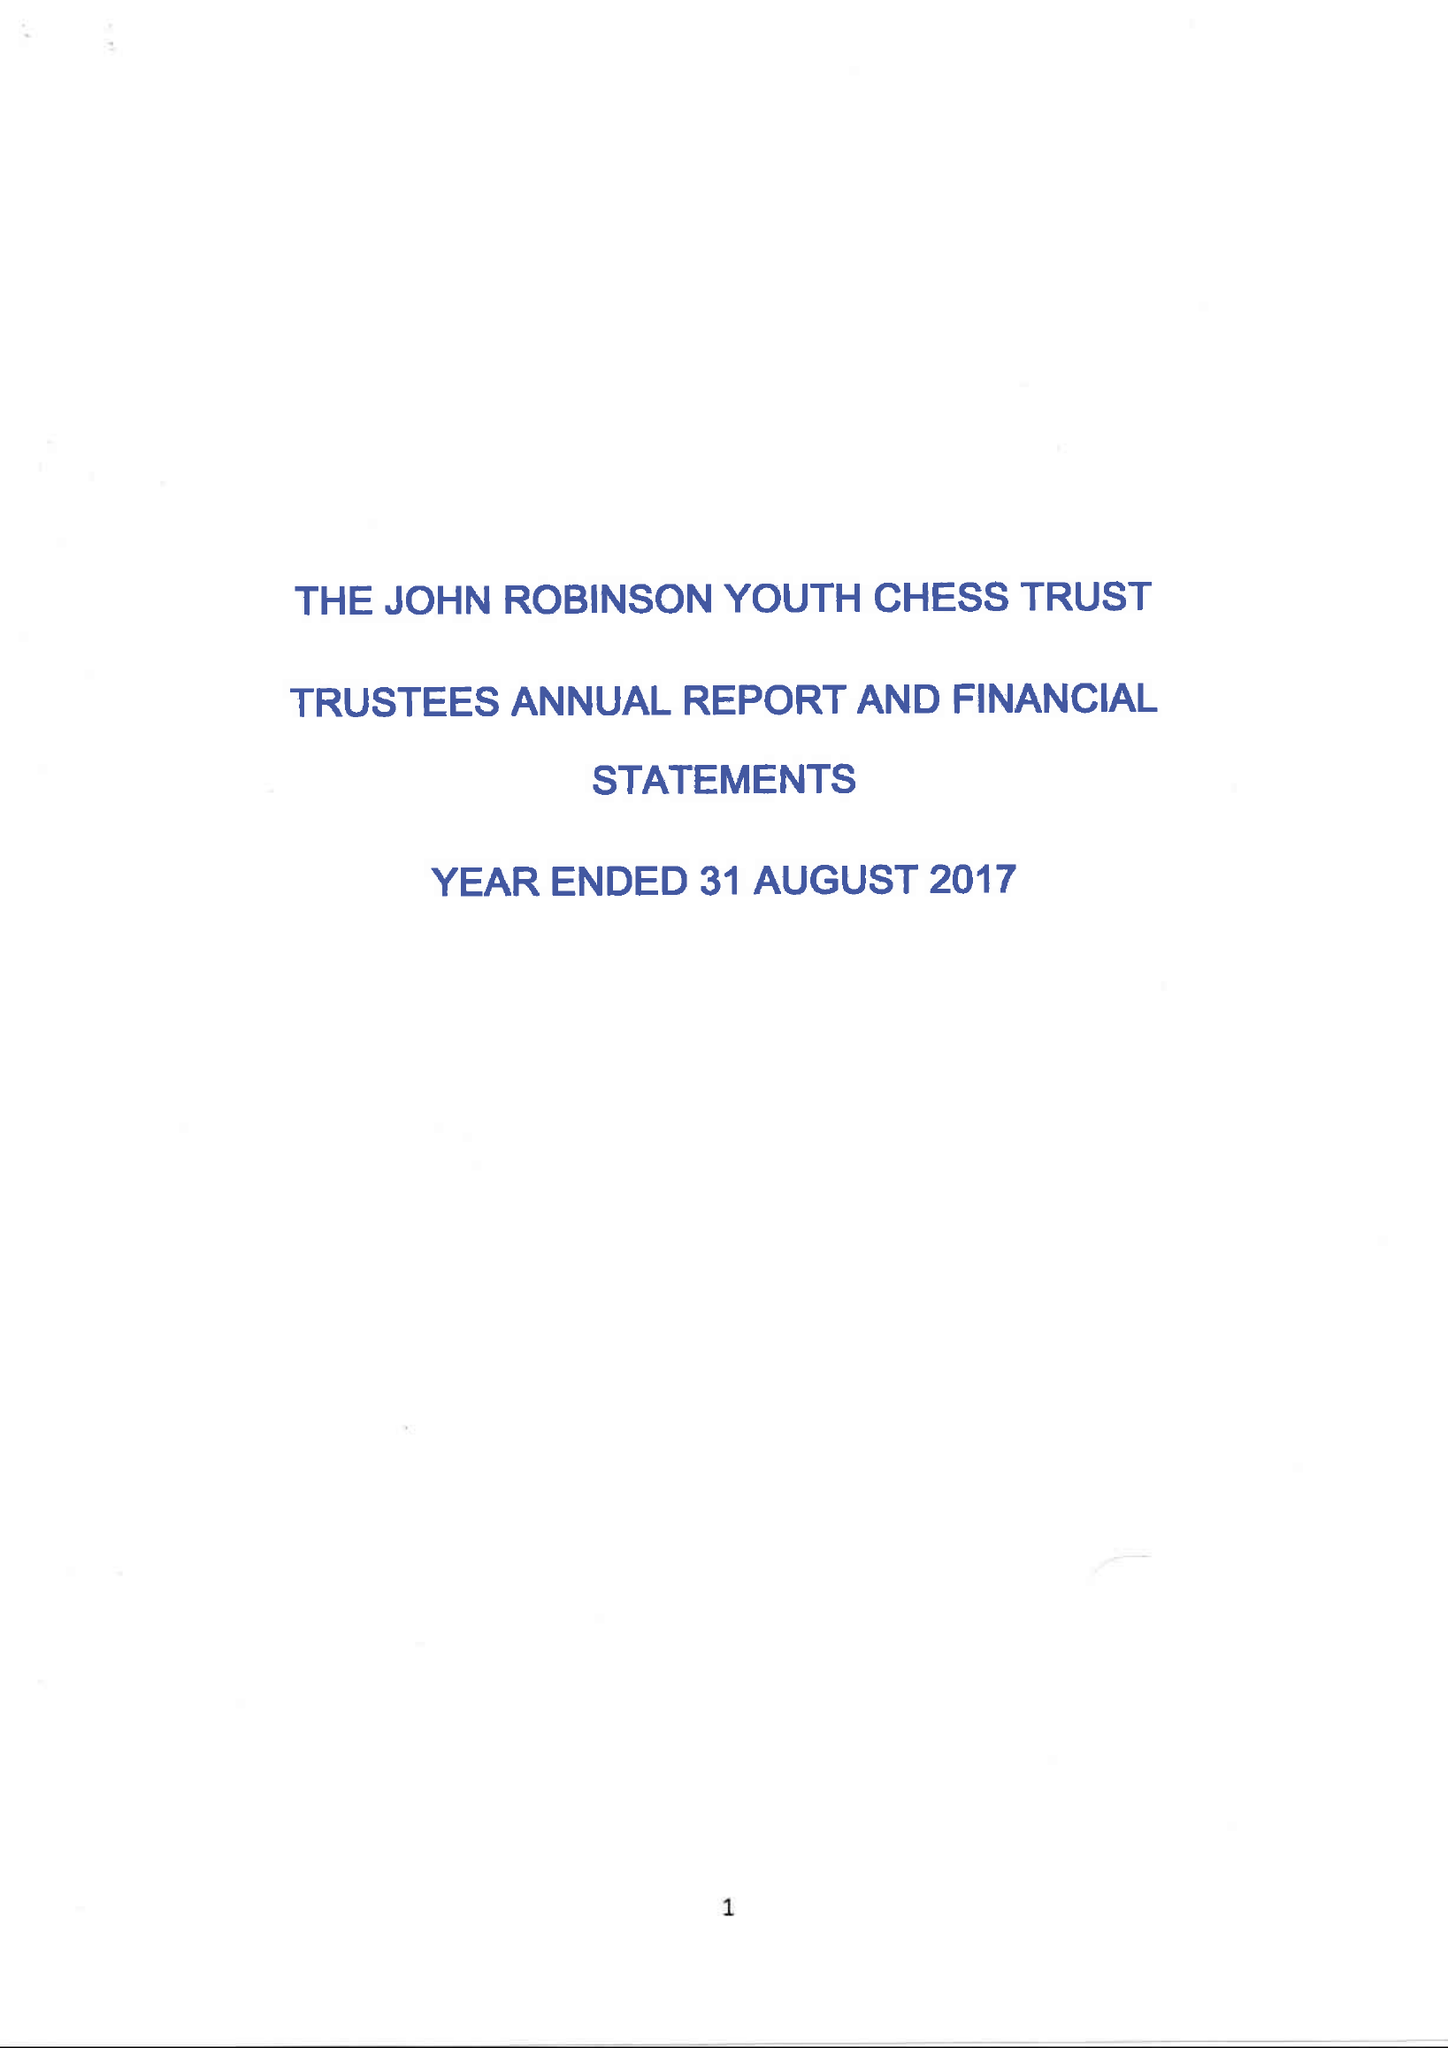What is the value for the spending_annually_in_british_pounds?
Answer the question using a single word or phrase. 30356.00 